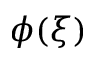Convert formula to latex. <formula><loc_0><loc_0><loc_500><loc_500>\phi ( \xi )</formula> 